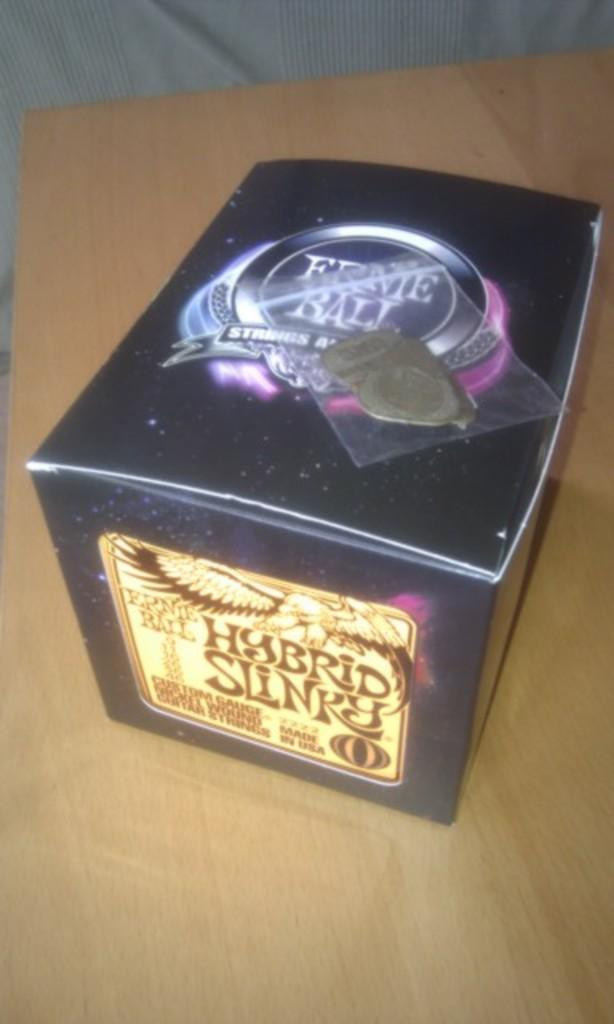<image>
Create a compact narrative representing the image presented. Black box titled Hybrid Slinky on top of a wooden table. 